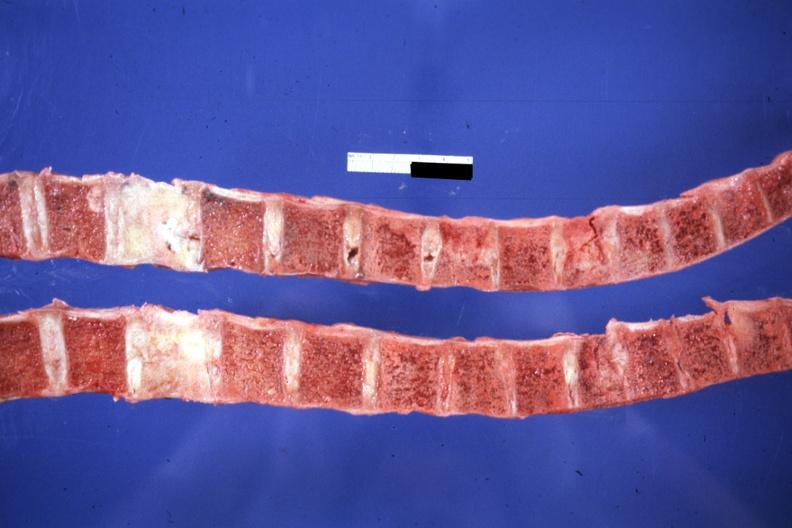what is present?
Answer the question using a single word or phrase. Joints 